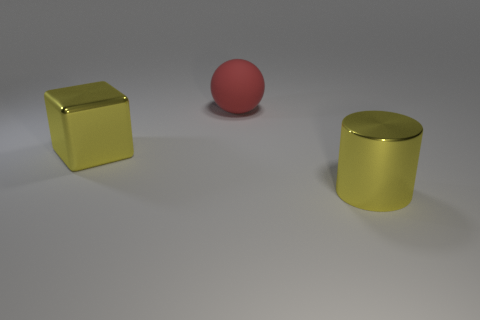Is there any other thing that is the same material as the big cube?
Give a very brief answer. Yes. There is a cube that is the same color as the cylinder; what size is it?
Give a very brief answer. Large. What material is the object that is the same color as the large shiny cylinder?
Your answer should be compact. Metal. There is a big yellow thing that is left of the big red matte ball; is it the same shape as the large metallic object that is on the right side of the large red sphere?
Provide a succinct answer. No. Is the number of rubber spheres right of the yellow cylinder greater than the number of tiny cyan cubes?
Ensure brevity in your answer.  No. How many things are large red objects or metallic cubes?
Offer a very short reply. 2. What is the color of the large rubber thing?
Your answer should be very brief. Red. What number of other objects are the same color as the shiny cylinder?
Ensure brevity in your answer.  1. There is a big red object; are there any shiny blocks in front of it?
Provide a succinct answer. Yes. The metallic thing that is behind the large yellow shiny thing that is on the right side of the large yellow metal object that is behind the yellow cylinder is what color?
Keep it short and to the point. Yellow. 